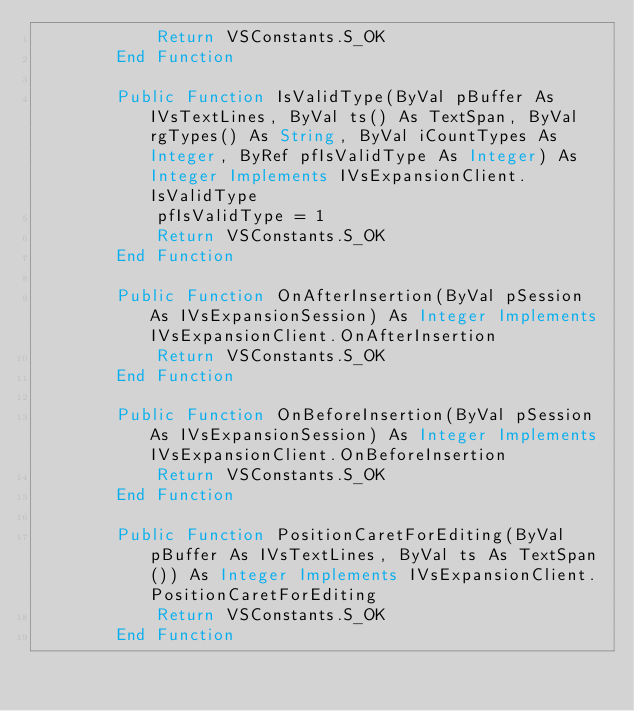<code> <loc_0><loc_0><loc_500><loc_500><_VisualBasic_>            Return VSConstants.S_OK
        End Function

        Public Function IsValidType(ByVal pBuffer As IVsTextLines, ByVal ts() As TextSpan, ByVal rgTypes() As String, ByVal iCountTypes As Integer, ByRef pfIsValidType As Integer) As Integer Implements IVsExpansionClient.IsValidType
            pfIsValidType = 1
            Return VSConstants.S_OK
        End Function

        Public Function OnAfterInsertion(ByVal pSession As IVsExpansionSession) As Integer Implements IVsExpansionClient.OnAfterInsertion
            Return VSConstants.S_OK
        End Function

        Public Function OnBeforeInsertion(ByVal pSession As IVsExpansionSession) As Integer Implements IVsExpansionClient.OnBeforeInsertion
            Return VSConstants.S_OK
        End Function

        Public Function PositionCaretForEditing(ByVal pBuffer As IVsTextLines, ByVal ts As TextSpan()) As Integer Implements IVsExpansionClient.PositionCaretForEditing
            Return VSConstants.S_OK
        End Function</code> 